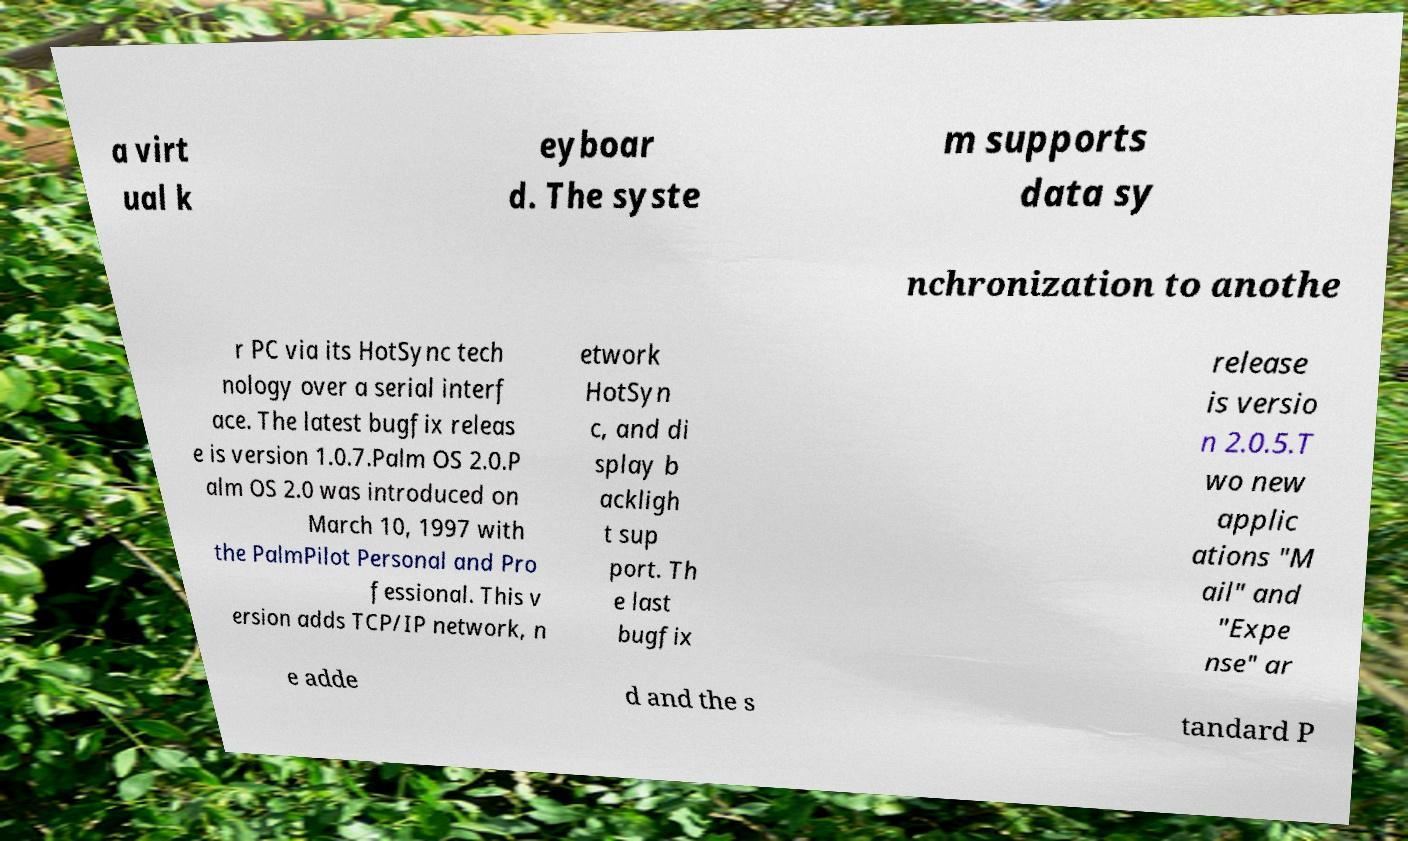Could you extract and type out the text from this image? a virt ual k eyboar d. The syste m supports data sy nchronization to anothe r PC via its HotSync tech nology over a serial interf ace. The latest bugfix releas e is version 1.0.7.Palm OS 2.0.P alm OS 2.0 was introduced on March 10, 1997 with the PalmPilot Personal and Pro fessional. This v ersion adds TCP/IP network, n etwork HotSyn c, and di splay b ackligh t sup port. Th e last bugfix release is versio n 2.0.5.T wo new applic ations "M ail" and "Expe nse" ar e adde d and the s tandard P 